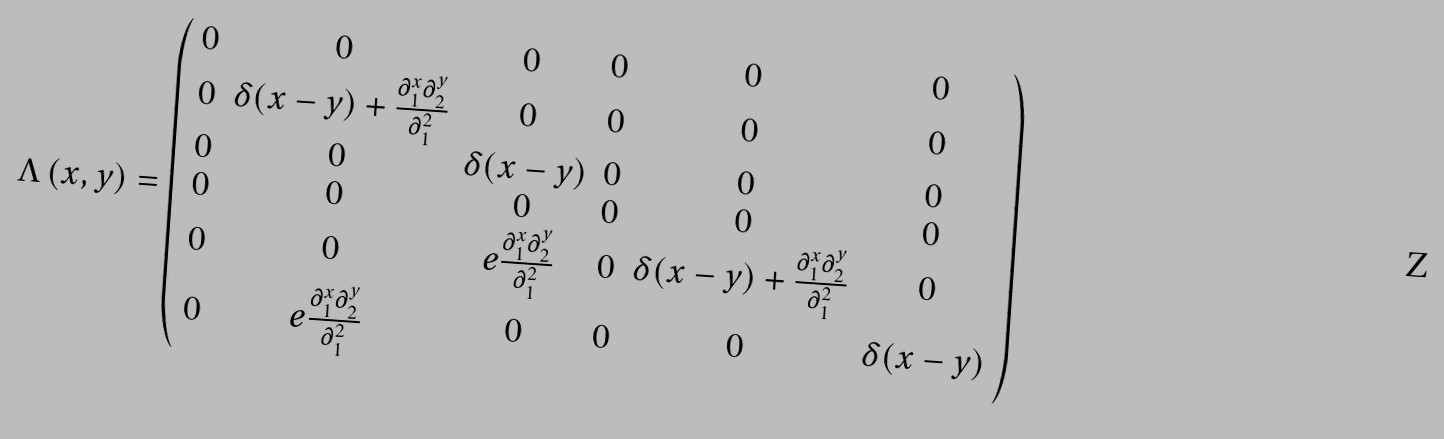<formula> <loc_0><loc_0><loc_500><loc_500>\Lambda \left ( x , y \right ) = \left ( \begin{array} { c c c c c c } 0 & 0 & 0 & 0 & 0 & 0 \\ 0 & \delta ( x - y ) + \frac { \partial _ { 1 } ^ { x } \partial _ { 2 } ^ { y } } { \partial _ { 1 } ^ { 2 } } & 0 & 0 & 0 & 0 \\ 0 & 0 & \delta ( x - y ) & 0 & 0 & 0 \\ 0 & 0 & 0 & 0 & 0 & 0 \\ 0 & 0 & e \frac { \partial _ { 1 } ^ { x } \partial _ { 2 } ^ { y } } { \partial _ { 1 } ^ { 2 } } & 0 & \delta ( x - y ) + \frac { \partial _ { 1 } ^ { x } \partial _ { 2 } ^ { y } } { \partial _ { 1 } ^ { 2 } } & 0 \\ 0 & e \frac { \partial _ { 1 } ^ { x } \partial _ { 2 } ^ { y } } { \partial _ { 1 } ^ { 2 } } & 0 & 0 & 0 & \delta ( x - y ) \end{array} \right )</formula> 